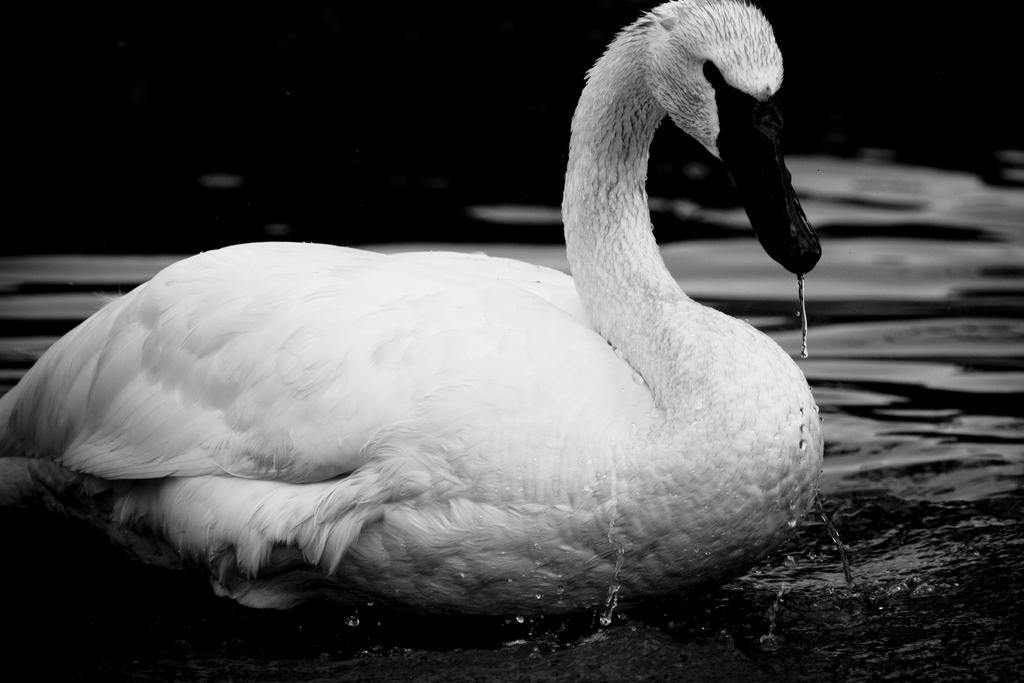What type of animal can be seen in the image? There is a bird in the image. What is the primary element in which the bird is situated? There is water visible in the image, and the bird appears to be in or near the water. What can be observed about the background of the image? The background of the image appears to be dark. What type of dirt can be seen on the bird's beak in the image? There is no dirt visible on the bird's beak in the image. How does the loaf of bread affect the bird's behavior in the image? There is no loaf of bread present in the image, so it cannot affect the bird's behavior. 